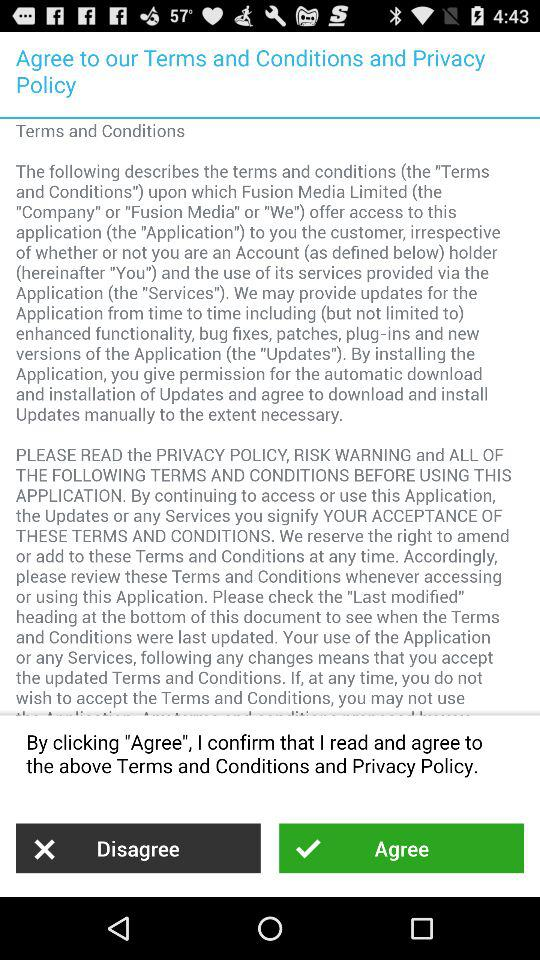What are the terms and conditions? The terms and conditions are "The following describes the terms and conditions (the "Terms and Conditions") upon which Fusion Media Limited (the "Company" or "Fusion Media" or "We") offer access to this application (the "Application") to you the customer, irrespective of whether or not you are an Account (as defined below) holder (hereinafter "You") and the use of its services provided via the Application (the "Services"). We may provide updates for the Application from time to time including (but not limited to) enhanced functionality, bug fixes, patches, plug-ins and new versions of the Application (the "Updates"). By installing the Application, you give permission for the automatic download and installation of Updates and agree to download and install Updates manually to the extent necessary. PLEASE READ the PRIVACY POLICY, RISK WARNING and ALL OF THE FOLLOWING TERMS AND CONDITIONS BEFORE USING THIS APPLICATION. By continuing to access or use this Application, the Updates or any Services you signify YOUR ACCEPTANCE OF THESE TERMS AND CONDITIONS. We reserve the right to amend or add to these Terms and Conditions at any time. Accordingly, please review these Terms and Conditions whenever accessing or using this Application. Please check the "Last modified" heading at the bottom of this document to see when the Terms and Conditions were last updated. Your use of the Application or any Services, following any changes means that you accept the updated Terms and Conditions. If, at any time, you do not wish to accept the Terms and Conditions, you may not use". 